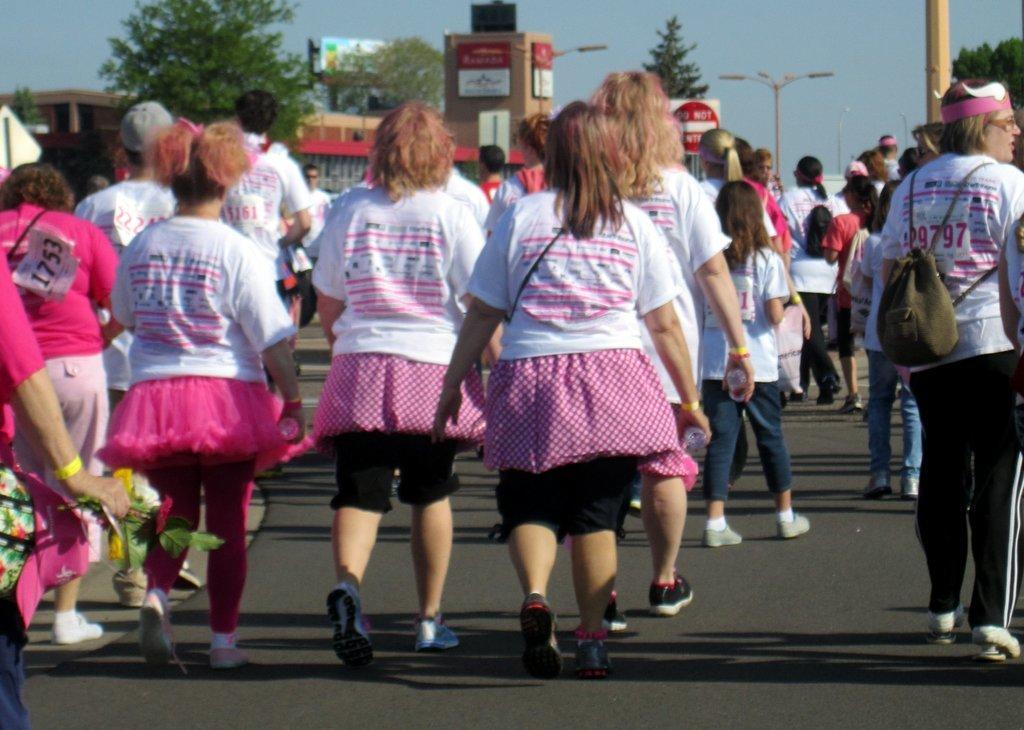Describe this image in one or two sentences. In this picture we can see a group of people are walking on the road and some of them are wearing bags, boards. On the boards we can see the text. In the background of the image we can see the buildings, boards, trees, poles, lights. On the left side of the image we can see a person is holding the flowers. At the bottom of the image we can see the road. At the top of the image we can see the sky. 